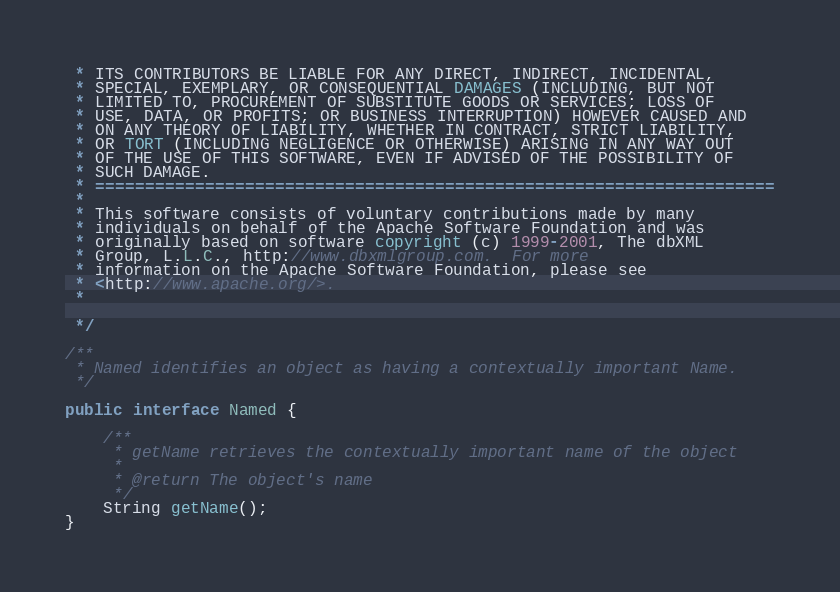<code> <loc_0><loc_0><loc_500><loc_500><_Java_> * ITS CONTRIBUTORS BE LIABLE FOR ANY DIRECT, INDIRECT, INCIDENTAL,
 * SPECIAL, EXEMPLARY, OR CONSEQUENTIAL DAMAGES (INCLUDING, BUT NOT
 * LIMITED TO, PROCUREMENT OF SUBSTITUTE GOODS OR SERVICES; LOSS OF
 * USE, DATA, OR PROFITS; OR BUSINESS INTERRUPTION) HOWEVER CAUSED AND
 * ON ANY THEORY OF LIABILITY, WHETHER IN CONTRACT, STRICT LIABILITY,
 * OR TORT (INCLUDING NEGLIGENCE OR OTHERWISE) ARISING IN ANY WAY OUT
 * OF THE USE OF THIS SOFTWARE, EVEN IF ADVISED OF THE POSSIBILITY OF
 * SUCH DAMAGE.
 * ====================================================================
 *
 * This software consists of voluntary contributions made by many
 * individuals on behalf of the Apache Software Foundation and was
 * originally based on software copyright (c) 1999-2001, The dbXML
 * Group, L.L.C., http://www.dbxmlgroup.com.  For more
 * information on the Apache Software Foundation, please see
 * <http://www.apache.org/>.
 *

 */

/**
 * Named identifies an object as having a contextually important Name.
 */

public interface Named {

    /**
     * getName retrieves the contextually important name of the object
     *
     * @return The object's name
     */
    String getName();
}

</code> 